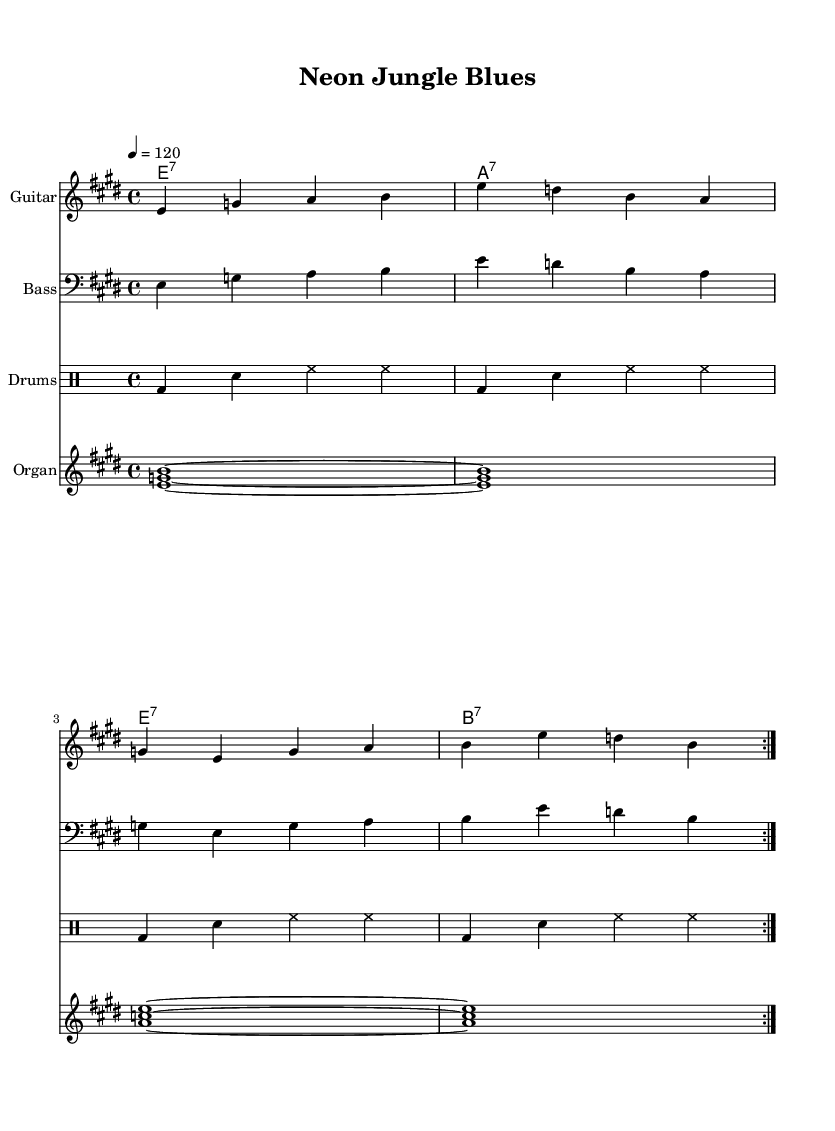What is the key signature of this music? The key signature is E major, which has four sharps (F#, C#, G#, D#). I can determine this by looking at the key signature indicated at the beginning of the score.
Answer: E major What is the time signature of this piece? The time signature is 4/4, which is clearly stated at the beginning of the score. This indicates there are four beats in each measure and the quarter note receives one beat.
Answer: 4/4 What is the tempo marking? The tempo marking is 120 beats per minute, shown by the indication '4 = 120' beneath the tempo section. This means that the quarter note is played at a speed of 120 beats per minute.
Answer: 120 How many measures are repeated in the guitar music? The guitar music has two measures repeated, as indicated by 'repeat volta 2' which shows that the section is played twice.
Answer: 2 What chords are used in the progression? The chords in the progression are E7, A7, and B7, which can be identified from the chord names written above the staff. These are characteristic chords found in Electric Blues.
Answer: E7, A7, B7 Which instrument has the highest pitch in this score? The instrument with the highest pitch in the score is the organ, as its music is written in a higher octave than the other instruments, making it stand out melodically.
Answer: Organ What feeling or mood does the 'Neon Jungle Blues' convey based on its title and music style? The title suggests a vibrant, lively atmosphere, typical of Electric Blues, often using expressive and emotive playing styles that promote feelings of excitement and energy.
Answer: Vibrant 